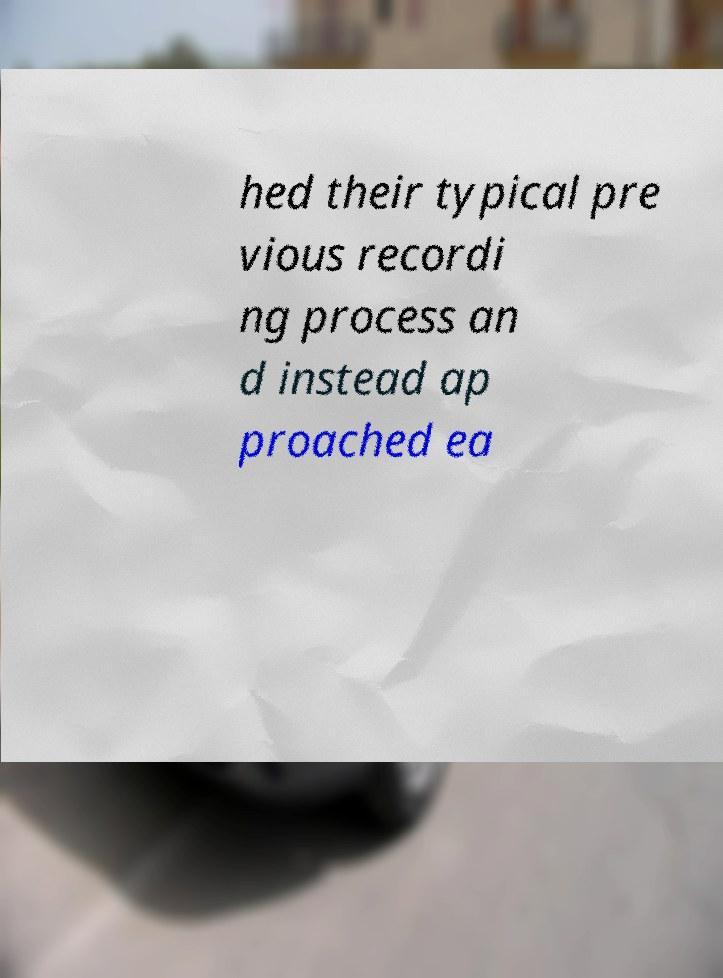Can you read and provide the text displayed in the image?This photo seems to have some interesting text. Can you extract and type it out for me? hed their typical pre vious recordi ng process an d instead ap proached ea 